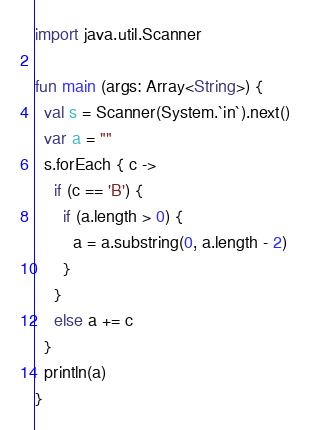Convert code to text. <code><loc_0><loc_0><loc_500><loc_500><_Kotlin_>import java.util.Scanner

fun main (args: Array<String>) {
  val s = Scanner(System.`in`).next()
  var a = ""
  s.forEach { c ->
    if (c == 'B') {
      if (a.length > 0) {
        a = a.substring(0, a.length - 2)
      }
    }
    else a += c
  }
  println(a)
}</code> 